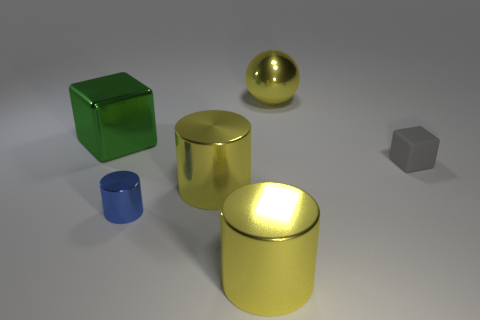Subtract all large cylinders. How many cylinders are left? 1 Subtract all blue blocks. How many yellow cylinders are left? 2 Subtract 1 cylinders. How many cylinders are left? 2 Add 2 large metal things. How many objects exist? 8 Subtract all cubes. How many objects are left? 4 Add 1 tiny brown rubber blocks. How many tiny brown rubber blocks exist? 1 Subtract 0 purple balls. How many objects are left? 6 Subtract all blue cubes. Subtract all brown balls. How many cubes are left? 2 Subtract all balls. Subtract all small matte cubes. How many objects are left? 4 Add 6 yellow cylinders. How many yellow cylinders are left? 8 